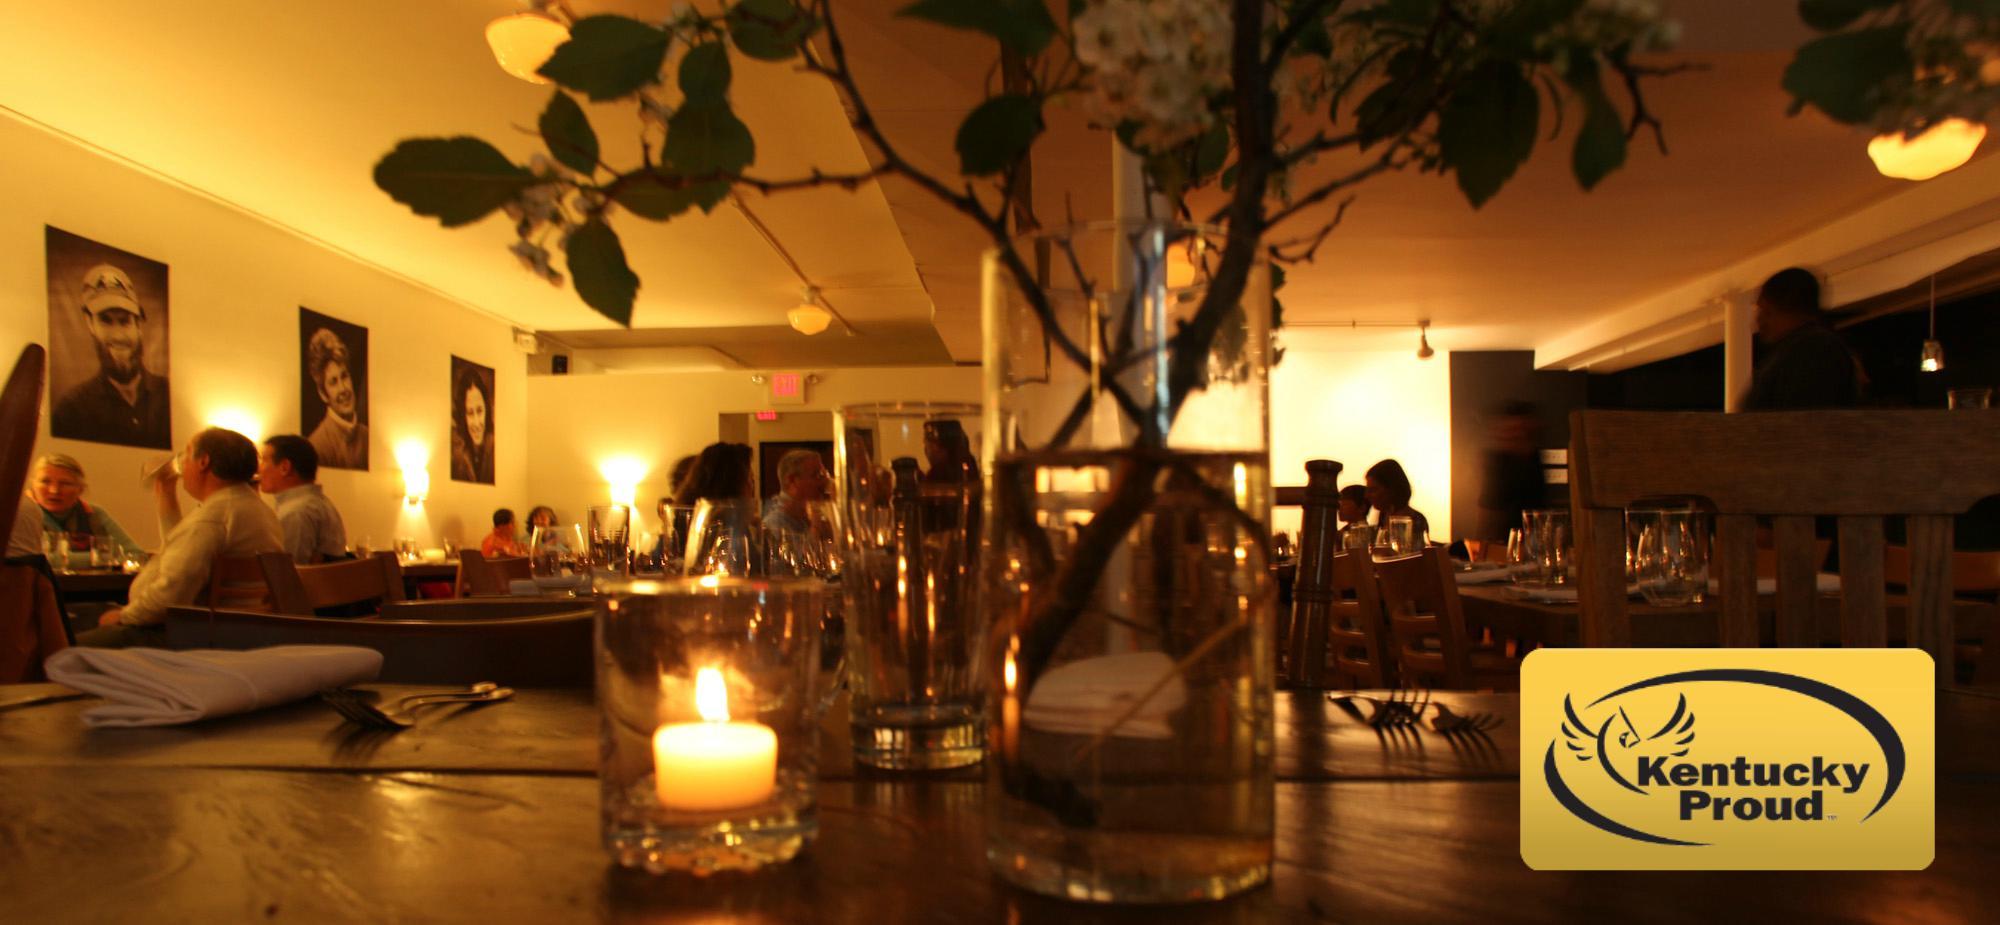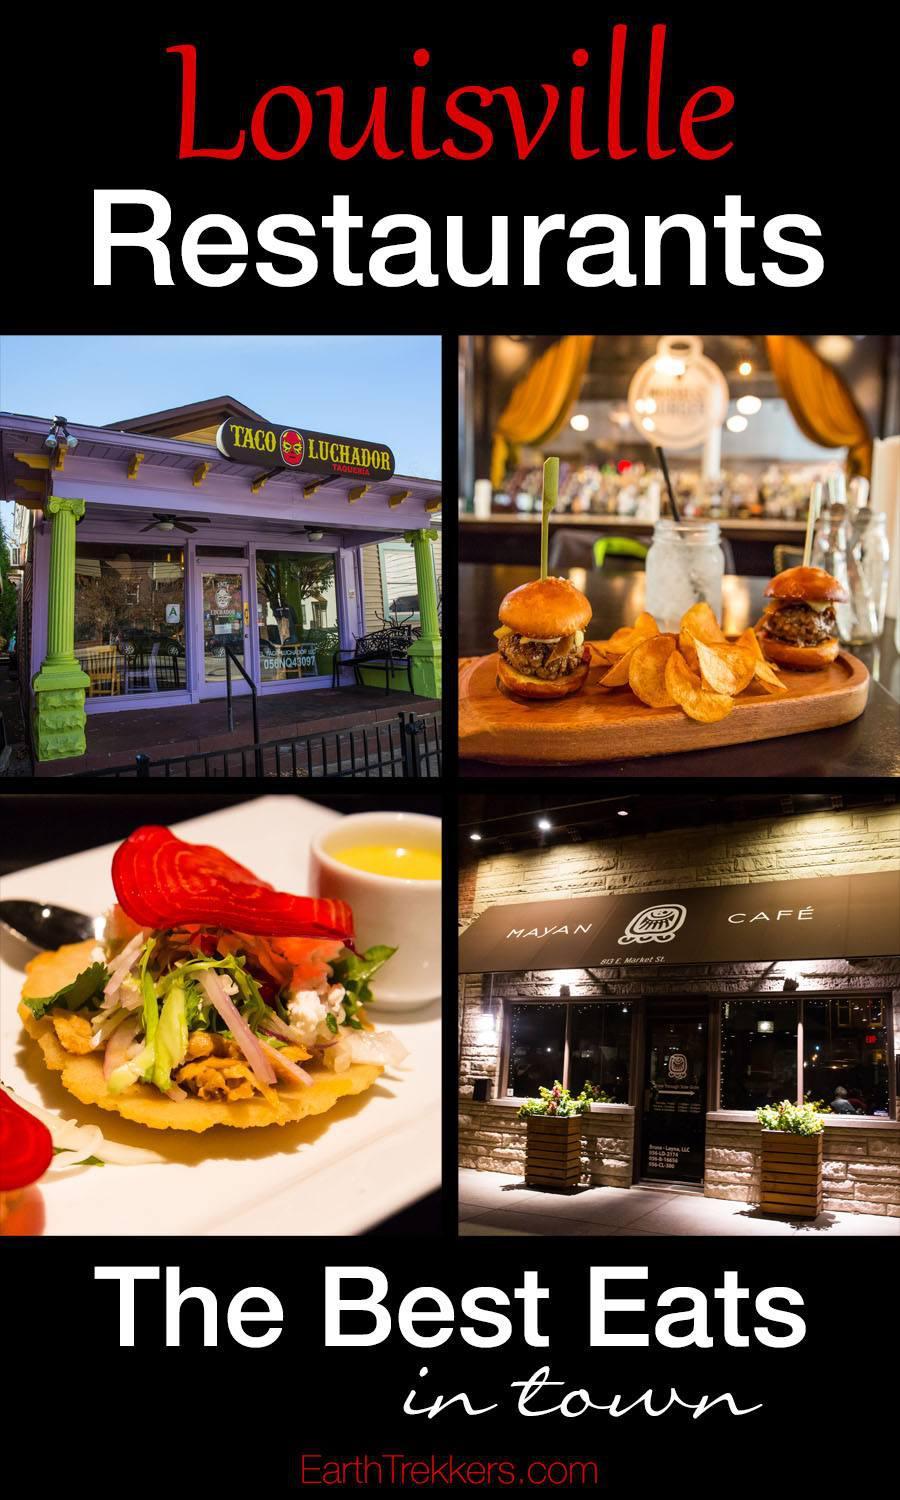The first image is the image on the left, the second image is the image on the right. Considering the images on both sides, is "The vacant dining tables have lit candles on them." valid? Answer yes or no. Yes. The first image is the image on the left, the second image is the image on the right. For the images displayed, is the sentence "There ae six dropped lights hanging over the long bar." factually correct? Answer yes or no. No. 